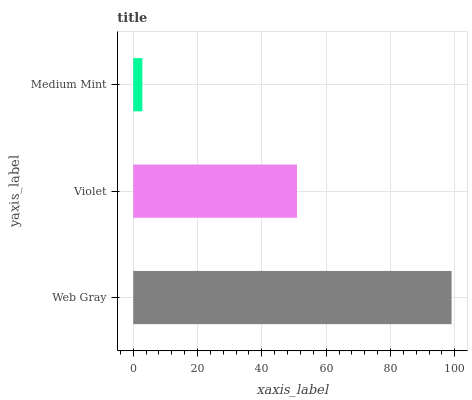Is Medium Mint the minimum?
Answer yes or no. Yes. Is Web Gray the maximum?
Answer yes or no. Yes. Is Violet the minimum?
Answer yes or no. No. Is Violet the maximum?
Answer yes or no. No. Is Web Gray greater than Violet?
Answer yes or no. Yes. Is Violet less than Web Gray?
Answer yes or no. Yes. Is Violet greater than Web Gray?
Answer yes or no. No. Is Web Gray less than Violet?
Answer yes or no. No. Is Violet the high median?
Answer yes or no. Yes. Is Violet the low median?
Answer yes or no. Yes. Is Web Gray the high median?
Answer yes or no. No. Is Medium Mint the low median?
Answer yes or no. No. 